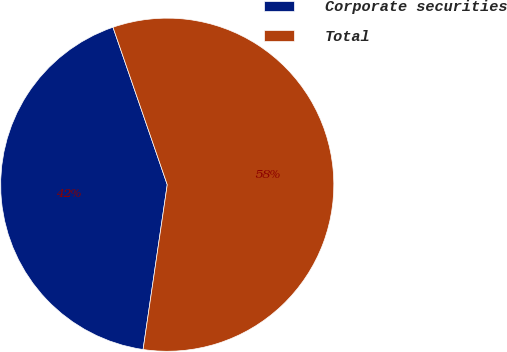Convert chart to OTSL. <chart><loc_0><loc_0><loc_500><loc_500><pie_chart><fcel>Corporate securities<fcel>Total<nl><fcel>42.4%<fcel>57.6%<nl></chart> 